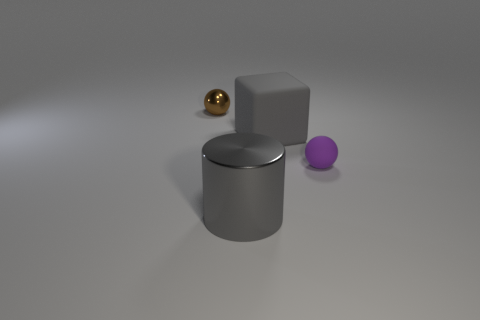What material is the large object behind the small ball right of the cylinder?
Offer a terse response. Rubber. Are there any small purple rubber objects of the same shape as the gray rubber object?
Provide a succinct answer. No. What color is the rubber thing that is the same size as the brown shiny thing?
Provide a short and direct response. Purple. What number of things are gray objects left of the big gray cube or gray objects in front of the big gray block?
Offer a terse response. 1. How many objects are either metallic spheres or big cyan spheres?
Ensure brevity in your answer.  1. There is a thing that is on the left side of the large gray rubber cube and right of the brown shiny sphere; what is its size?
Make the answer very short. Large. How many tiny brown things have the same material as the large cylinder?
Your answer should be compact. 1. What is the color of the object that is the same material as the small brown ball?
Offer a terse response. Gray. Is the color of the cylinder to the left of the large rubber cube the same as the big cube?
Your answer should be compact. Yes. There is a tiny object that is behind the small purple sphere; what material is it?
Give a very brief answer. Metal. 